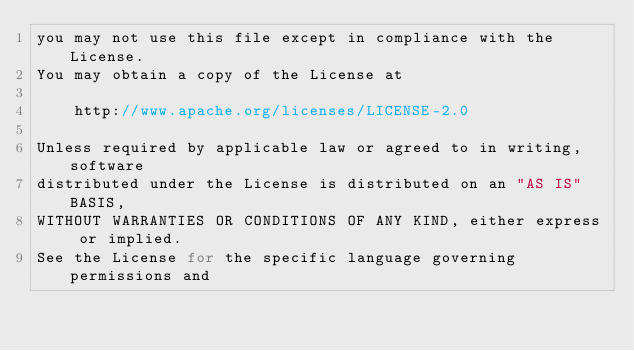Convert code to text. <code><loc_0><loc_0><loc_500><loc_500><_Go_>you may not use this file except in compliance with the License.
You may obtain a copy of the License at

    http://www.apache.org/licenses/LICENSE-2.0

Unless required by applicable law or agreed to in writing, software
distributed under the License is distributed on an "AS IS" BASIS,
WITHOUT WARRANTIES OR CONDITIONS OF ANY KIND, either express or implied.
See the License for the specific language governing permissions and</code> 